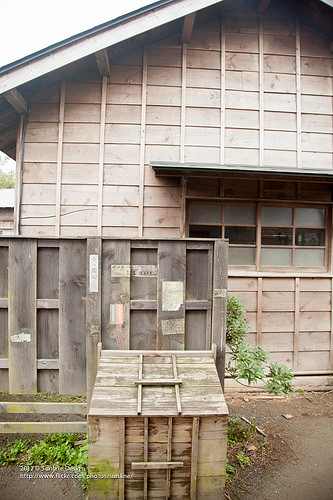<image>
Is the blind above the window? Yes. The blind is positioned above the window in the vertical space, higher up in the scene. 